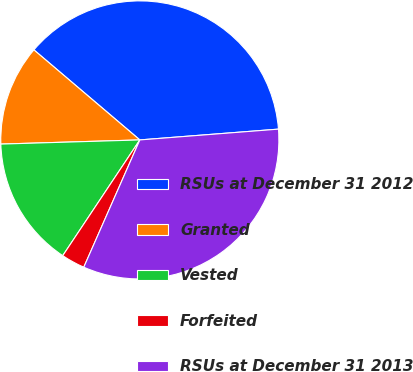Convert chart. <chart><loc_0><loc_0><loc_500><loc_500><pie_chart><fcel>RSUs at December 31 2012<fcel>Granted<fcel>Vested<fcel>Forfeited<fcel>RSUs at December 31 2013<nl><fcel>37.55%<fcel>11.69%<fcel>15.17%<fcel>2.75%<fcel>32.84%<nl></chart> 